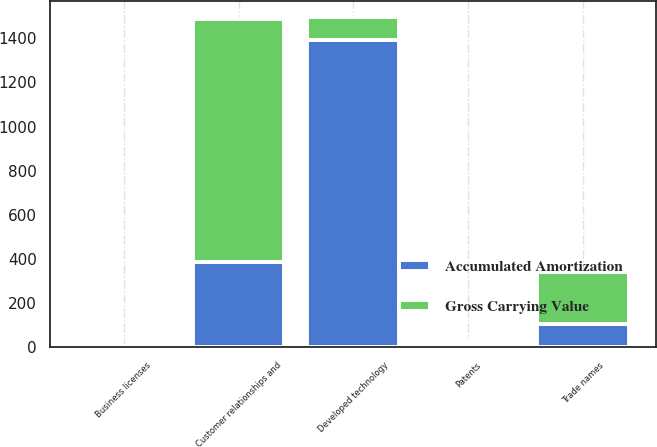Convert chart. <chart><loc_0><loc_0><loc_500><loc_500><stacked_bar_chart><ecel><fcel>Developed technology<fcel>Customer relationships and<fcel>Trade names<fcel>Patents<fcel>Business licenses<nl><fcel>Gross Carrying Value<fcel>105.3<fcel>1102.4<fcel>236.5<fcel>14.5<fcel>2.6<nl><fcel>Accumulated Amortization<fcel>1390.5<fcel>384.7<fcel>105.3<fcel>8.9<fcel>2<nl></chart> 